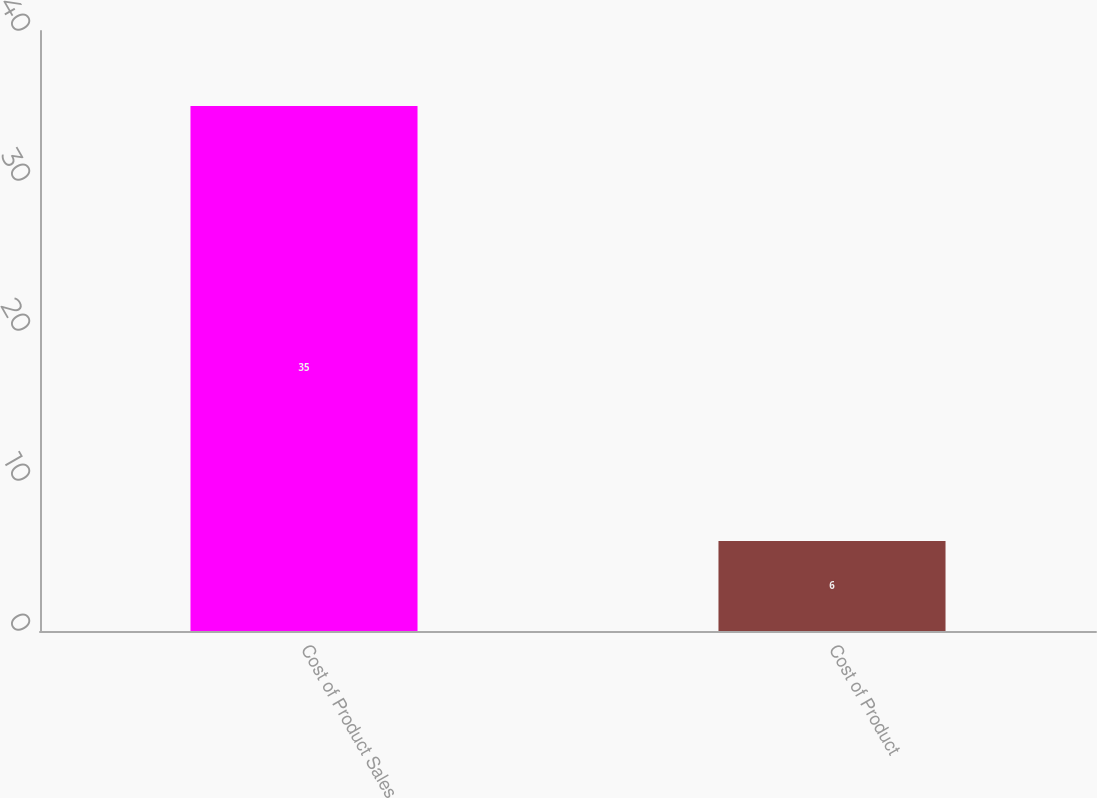Convert chart to OTSL. <chart><loc_0><loc_0><loc_500><loc_500><bar_chart><fcel>Cost of Product Sales<fcel>Cost of Product<nl><fcel>35<fcel>6<nl></chart> 